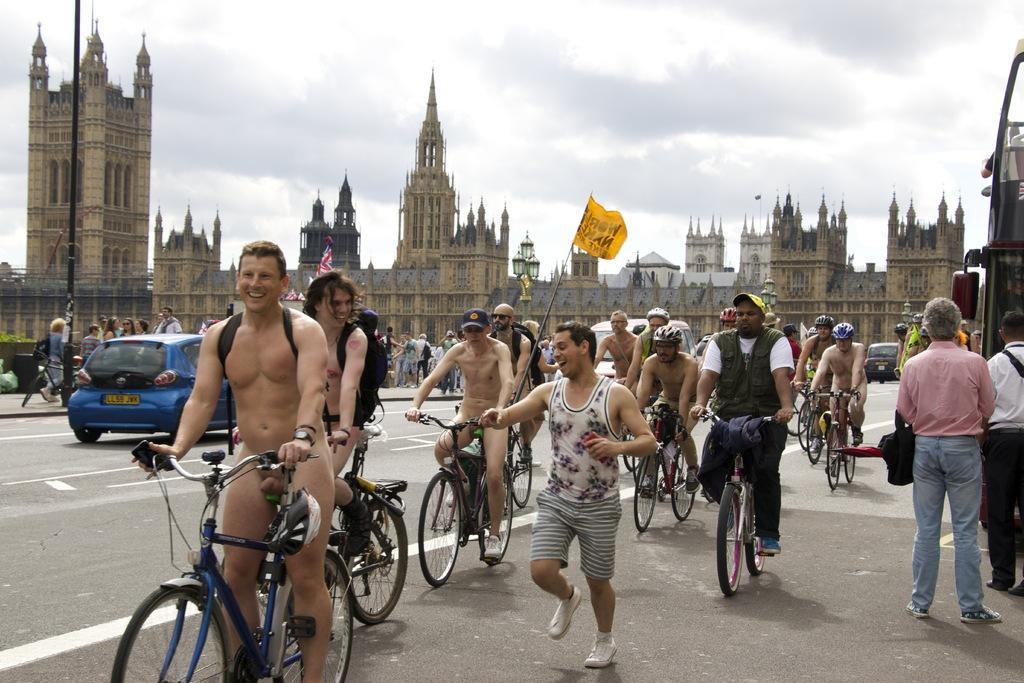In one or two sentences, can you explain what this image depicts? In this picture we can see some persons on the bicycles. This is road. And there is a car. Here we can see some buildings. And there is a pole. On the background we can see sky with clouds. 